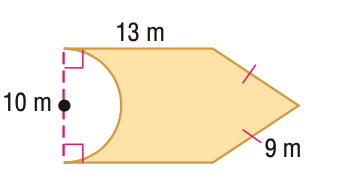Question: Find the area of the figure. Round to the nearest tenth if necessary.
Choices:
A. 88.9
B. 128.1
C. 165.6
D. 206.7
Answer with the letter. Answer: B 